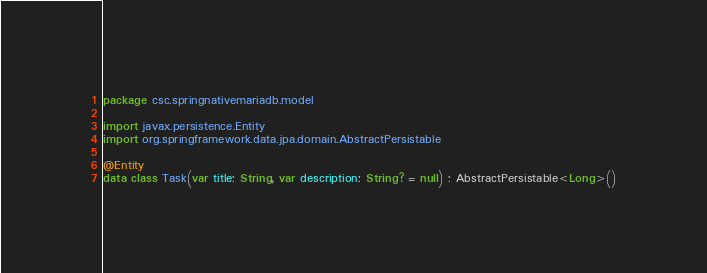<code> <loc_0><loc_0><loc_500><loc_500><_Kotlin_>package csc.springnativemariadb.model

import javax.persistence.Entity
import org.springframework.data.jpa.domain.AbstractPersistable

@Entity
data class Task(var title: String, var description: String? = null) : AbstractPersistable<Long>()
</code> 